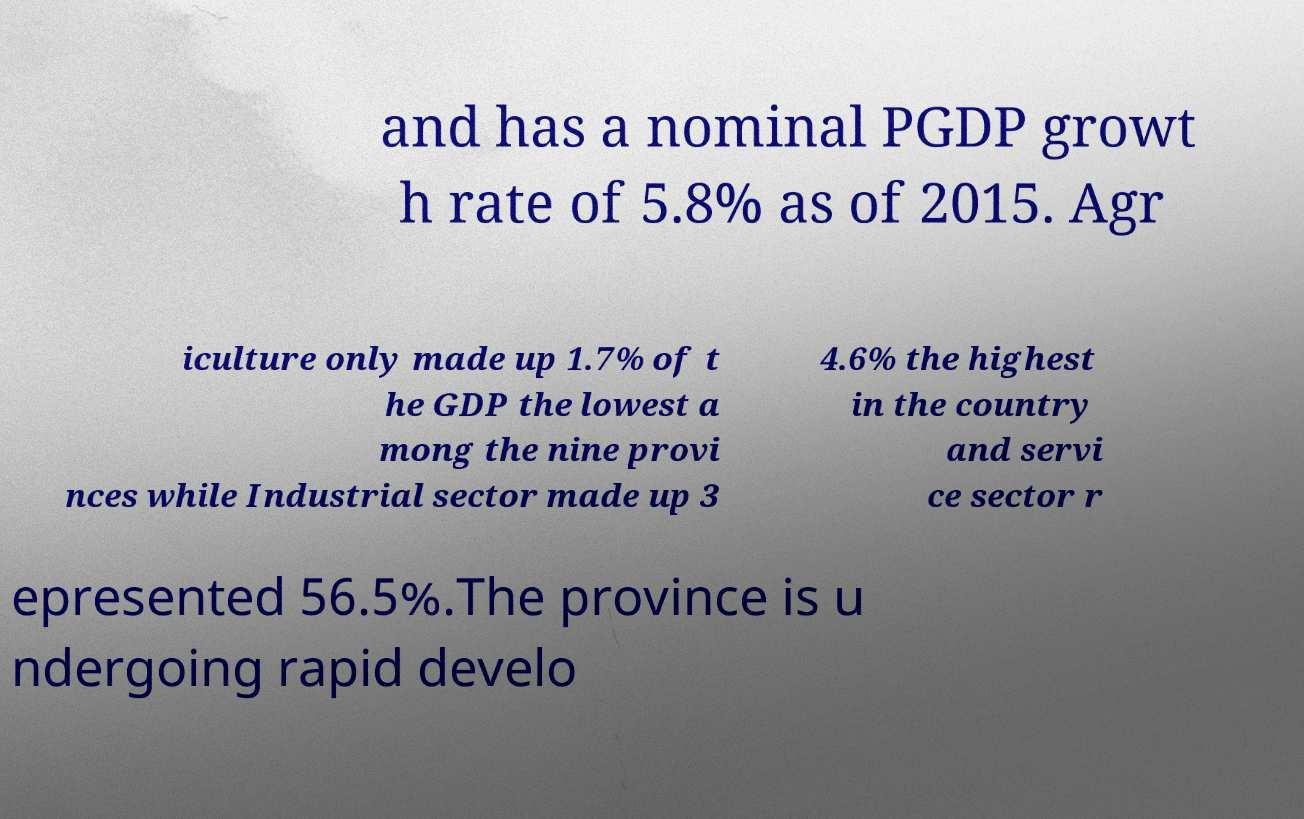Can you accurately transcribe the text from the provided image for me? and has a nominal PGDP growt h rate of 5.8% as of 2015. Agr iculture only made up 1.7% of t he GDP the lowest a mong the nine provi nces while Industrial sector made up 3 4.6% the highest in the country and servi ce sector r epresented 56.5%.The province is u ndergoing rapid develo 